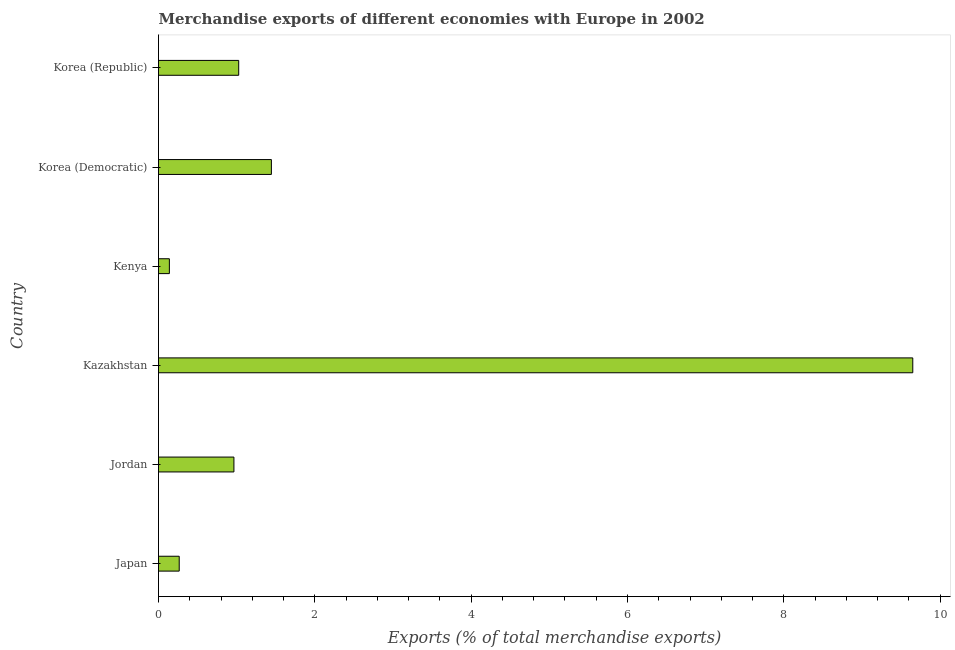Does the graph contain grids?
Ensure brevity in your answer.  No. What is the title of the graph?
Your answer should be compact. Merchandise exports of different economies with Europe in 2002. What is the label or title of the X-axis?
Provide a succinct answer. Exports (% of total merchandise exports). What is the label or title of the Y-axis?
Offer a very short reply. Country. What is the merchandise exports in Kenya?
Your response must be concise. 0.14. Across all countries, what is the maximum merchandise exports?
Give a very brief answer. 9.65. Across all countries, what is the minimum merchandise exports?
Your answer should be compact. 0.14. In which country was the merchandise exports maximum?
Give a very brief answer. Kazakhstan. In which country was the merchandise exports minimum?
Give a very brief answer. Kenya. What is the sum of the merchandise exports?
Provide a short and direct response. 13.49. What is the difference between the merchandise exports in Kazakhstan and Korea (Democratic)?
Your answer should be compact. 8.21. What is the average merchandise exports per country?
Offer a very short reply. 2.25. What is the median merchandise exports?
Offer a very short reply. 1. What is the ratio of the merchandise exports in Japan to that in Korea (Democratic)?
Make the answer very short. 0.18. What is the difference between the highest and the second highest merchandise exports?
Provide a succinct answer. 8.21. Is the sum of the merchandise exports in Japan and Kazakhstan greater than the maximum merchandise exports across all countries?
Your answer should be very brief. Yes. What is the difference between the highest and the lowest merchandise exports?
Make the answer very short. 9.51. In how many countries, is the merchandise exports greater than the average merchandise exports taken over all countries?
Your response must be concise. 1. How many bars are there?
Your answer should be very brief. 6. Are all the bars in the graph horizontal?
Offer a very short reply. Yes. How many countries are there in the graph?
Your response must be concise. 6. What is the difference between two consecutive major ticks on the X-axis?
Provide a short and direct response. 2. Are the values on the major ticks of X-axis written in scientific E-notation?
Your response must be concise. No. What is the Exports (% of total merchandise exports) of Japan?
Your response must be concise. 0.26. What is the Exports (% of total merchandise exports) of Jordan?
Give a very brief answer. 0.96. What is the Exports (% of total merchandise exports) in Kazakhstan?
Keep it short and to the point. 9.65. What is the Exports (% of total merchandise exports) in Kenya?
Give a very brief answer. 0.14. What is the Exports (% of total merchandise exports) in Korea (Democratic)?
Keep it short and to the point. 1.44. What is the Exports (% of total merchandise exports) in Korea (Republic)?
Provide a succinct answer. 1.03. What is the difference between the Exports (% of total merchandise exports) in Japan and Jordan?
Your response must be concise. -0.7. What is the difference between the Exports (% of total merchandise exports) in Japan and Kazakhstan?
Make the answer very short. -9.39. What is the difference between the Exports (% of total merchandise exports) in Japan and Kenya?
Your answer should be very brief. 0.13. What is the difference between the Exports (% of total merchandise exports) in Japan and Korea (Democratic)?
Ensure brevity in your answer.  -1.18. What is the difference between the Exports (% of total merchandise exports) in Japan and Korea (Republic)?
Your answer should be compact. -0.76. What is the difference between the Exports (% of total merchandise exports) in Jordan and Kazakhstan?
Provide a succinct answer. -8.69. What is the difference between the Exports (% of total merchandise exports) in Jordan and Kenya?
Your answer should be very brief. 0.83. What is the difference between the Exports (% of total merchandise exports) in Jordan and Korea (Democratic)?
Provide a succinct answer. -0.48. What is the difference between the Exports (% of total merchandise exports) in Jordan and Korea (Republic)?
Your answer should be compact. -0.06. What is the difference between the Exports (% of total merchandise exports) in Kazakhstan and Kenya?
Offer a terse response. 9.51. What is the difference between the Exports (% of total merchandise exports) in Kazakhstan and Korea (Democratic)?
Your answer should be very brief. 8.21. What is the difference between the Exports (% of total merchandise exports) in Kazakhstan and Korea (Republic)?
Provide a succinct answer. 8.62. What is the difference between the Exports (% of total merchandise exports) in Kenya and Korea (Democratic)?
Keep it short and to the point. -1.31. What is the difference between the Exports (% of total merchandise exports) in Kenya and Korea (Republic)?
Provide a succinct answer. -0.89. What is the difference between the Exports (% of total merchandise exports) in Korea (Democratic) and Korea (Republic)?
Your response must be concise. 0.42. What is the ratio of the Exports (% of total merchandise exports) in Japan to that in Jordan?
Offer a terse response. 0.28. What is the ratio of the Exports (% of total merchandise exports) in Japan to that in Kazakhstan?
Offer a very short reply. 0.03. What is the ratio of the Exports (% of total merchandise exports) in Japan to that in Kenya?
Your response must be concise. 1.91. What is the ratio of the Exports (% of total merchandise exports) in Japan to that in Korea (Democratic)?
Provide a succinct answer. 0.18. What is the ratio of the Exports (% of total merchandise exports) in Japan to that in Korea (Republic)?
Your response must be concise. 0.26. What is the ratio of the Exports (% of total merchandise exports) in Jordan to that in Kazakhstan?
Keep it short and to the point. 0.1. What is the ratio of the Exports (% of total merchandise exports) in Jordan to that in Kenya?
Give a very brief answer. 6.94. What is the ratio of the Exports (% of total merchandise exports) in Jordan to that in Korea (Democratic)?
Ensure brevity in your answer.  0.67. What is the ratio of the Exports (% of total merchandise exports) in Jordan to that in Korea (Republic)?
Your response must be concise. 0.94. What is the ratio of the Exports (% of total merchandise exports) in Kazakhstan to that in Kenya?
Offer a very short reply. 69.44. What is the ratio of the Exports (% of total merchandise exports) in Kazakhstan to that in Korea (Democratic)?
Your response must be concise. 6.68. What is the ratio of the Exports (% of total merchandise exports) in Kazakhstan to that in Korea (Republic)?
Ensure brevity in your answer.  9.41. What is the ratio of the Exports (% of total merchandise exports) in Kenya to that in Korea (Democratic)?
Your answer should be very brief. 0.1. What is the ratio of the Exports (% of total merchandise exports) in Kenya to that in Korea (Republic)?
Provide a succinct answer. 0.14. What is the ratio of the Exports (% of total merchandise exports) in Korea (Democratic) to that in Korea (Republic)?
Provide a succinct answer. 1.41. 